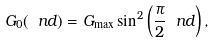<formula> <loc_0><loc_0><loc_500><loc_500>G _ { 0 } ( \ n d ) = G _ { \max } \sin ^ { 2 } \left ( \frac { \pi } { 2 } \ n d \right ) ,</formula> 